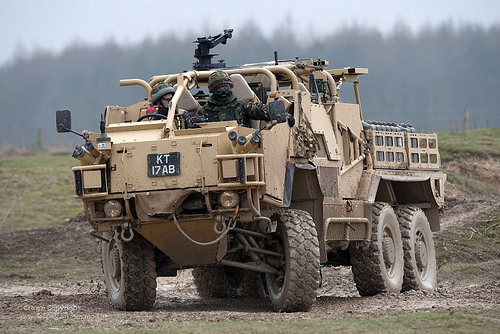<image>
Can you confirm if the gun is on the vehicle? Yes. Looking at the image, I can see the gun is positioned on top of the vehicle, with the vehicle providing support. Is there a helmet on the man? No. The helmet is not positioned on the man. They may be near each other, but the helmet is not supported by or resting on top of the man. Where is the sky in relation to the forest? Is it behind the forest? Yes. From this viewpoint, the sky is positioned behind the forest, with the forest partially or fully occluding the sky. 